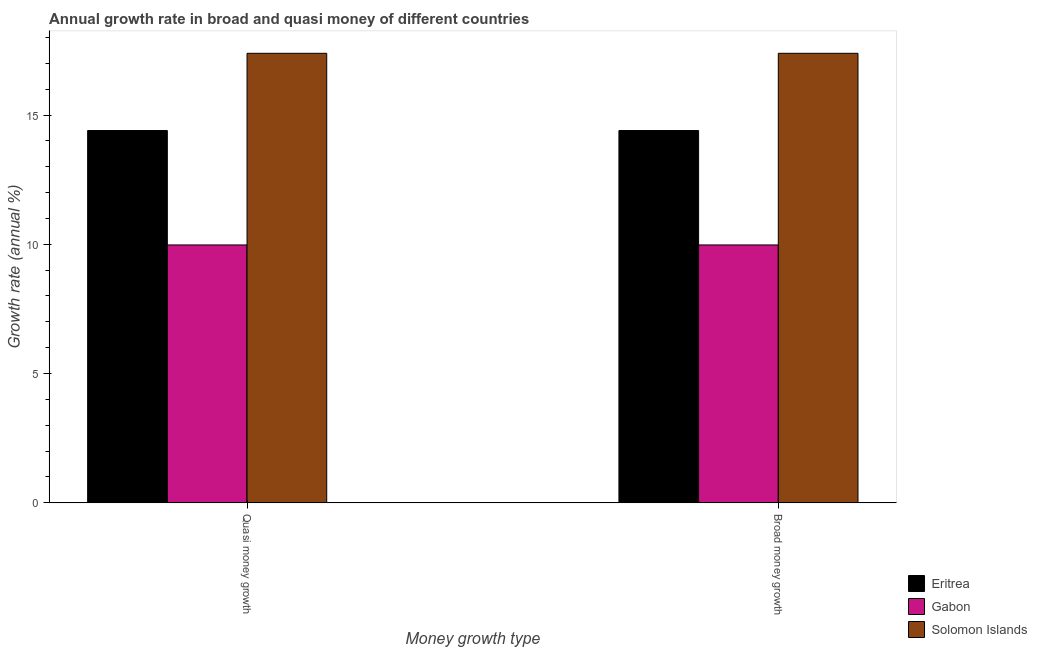How many groups of bars are there?
Give a very brief answer. 2. How many bars are there on the 2nd tick from the left?
Provide a succinct answer. 3. What is the label of the 2nd group of bars from the left?
Provide a short and direct response. Broad money growth. What is the annual growth rate in broad money in Gabon?
Provide a short and direct response. 9.97. Across all countries, what is the maximum annual growth rate in broad money?
Offer a very short reply. 17.39. Across all countries, what is the minimum annual growth rate in broad money?
Your response must be concise. 9.97. In which country was the annual growth rate in broad money maximum?
Offer a very short reply. Solomon Islands. In which country was the annual growth rate in quasi money minimum?
Your answer should be compact. Gabon. What is the total annual growth rate in quasi money in the graph?
Your response must be concise. 41.76. What is the difference between the annual growth rate in broad money in Eritrea and that in Gabon?
Make the answer very short. 4.43. What is the difference between the annual growth rate in broad money in Eritrea and the annual growth rate in quasi money in Gabon?
Your answer should be compact. 4.43. What is the average annual growth rate in quasi money per country?
Your answer should be very brief. 13.92. What is the ratio of the annual growth rate in quasi money in Solomon Islands to that in Gabon?
Provide a short and direct response. 1.74. In how many countries, is the annual growth rate in broad money greater than the average annual growth rate in broad money taken over all countries?
Ensure brevity in your answer.  2. What does the 2nd bar from the left in Broad money growth represents?
Ensure brevity in your answer.  Gabon. What does the 2nd bar from the right in Quasi money growth represents?
Give a very brief answer. Gabon. How many bars are there?
Provide a short and direct response. 6. How many countries are there in the graph?
Your response must be concise. 3. What is the difference between two consecutive major ticks on the Y-axis?
Your response must be concise. 5. Are the values on the major ticks of Y-axis written in scientific E-notation?
Your answer should be compact. No. Does the graph contain any zero values?
Give a very brief answer. No. How are the legend labels stacked?
Your answer should be very brief. Vertical. What is the title of the graph?
Your response must be concise. Annual growth rate in broad and quasi money of different countries. What is the label or title of the X-axis?
Offer a terse response. Money growth type. What is the label or title of the Y-axis?
Ensure brevity in your answer.  Growth rate (annual %). What is the Growth rate (annual %) of Eritrea in Quasi money growth?
Provide a short and direct response. 14.4. What is the Growth rate (annual %) in Gabon in Quasi money growth?
Ensure brevity in your answer.  9.97. What is the Growth rate (annual %) of Solomon Islands in Quasi money growth?
Ensure brevity in your answer.  17.39. What is the Growth rate (annual %) of Eritrea in Broad money growth?
Provide a succinct answer. 14.4. What is the Growth rate (annual %) of Gabon in Broad money growth?
Your answer should be compact. 9.97. What is the Growth rate (annual %) of Solomon Islands in Broad money growth?
Keep it short and to the point. 17.39. Across all Money growth type, what is the maximum Growth rate (annual %) of Eritrea?
Keep it short and to the point. 14.4. Across all Money growth type, what is the maximum Growth rate (annual %) of Gabon?
Keep it short and to the point. 9.97. Across all Money growth type, what is the maximum Growth rate (annual %) in Solomon Islands?
Keep it short and to the point. 17.39. Across all Money growth type, what is the minimum Growth rate (annual %) in Eritrea?
Ensure brevity in your answer.  14.4. Across all Money growth type, what is the minimum Growth rate (annual %) in Gabon?
Your answer should be compact. 9.97. Across all Money growth type, what is the minimum Growth rate (annual %) of Solomon Islands?
Give a very brief answer. 17.39. What is the total Growth rate (annual %) in Eritrea in the graph?
Offer a terse response. 28.8. What is the total Growth rate (annual %) of Gabon in the graph?
Provide a succinct answer. 19.95. What is the total Growth rate (annual %) in Solomon Islands in the graph?
Keep it short and to the point. 34.77. What is the difference between the Growth rate (annual %) in Gabon in Quasi money growth and that in Broad money growth?
Your response must be concise. 0. What is the difference between the Growth rate (annual %) of Eritrea in Quasi money growth and the Growth rate (annual %) of Gabon in Broad money growth?
Give a very brief answer. 4.43. What is the difference between the Growth rate (annual %) of Eritrea in Quasi money growth and the Growth rate (annual %) of Solomon Islands in Broad money growth?
Your answer should be very brief. -2.99. What is the difference between the Growth rate (annual %) in Gabon in Quasi money growth and the Growth rate (annual %) in Solomon Islands in Broad money growth?
Your answer should be compact. -7.41. What is the average Growth rate (annual %) of Eritrea per Money growth type?
Your answer should be very brief. 14.4. What is the average Growth rate (annual %) of Gabon per Money growth type?
Your answer should be compact. 9.97. What is the average Growth rate (annual %) in Solomon Islands per Money growth type?
Keep it short and to the point. 17.39. What is the difference between the Growth rate (annual %) in Eritrea and Growth rate (annual %) in Gabon in Quasi money growth?
Provide a short and direct response. 4.43. What is the difference between the Growth rate (annual %) in Eritrea and Growth rate (annual %) in Solomon Islands in Quasi money growth?
Offer a terse response. -2.99. What is the difference between the Growth rate (annual %) of Gabon and Growth rate (annual %) of Solomon Islands in Quasi money growth?
Provide a succinct answer. -7.41. What is the difference between the Growth rate (annual %) of Eritrea and Growth rate (annual %) of Gabon in Broad money growth?
Your answer should be compact. 4.43. What is the difference between the Growth rate (annual %) in Eritrea and Growth rate (annual %) in Solomon Islands in Broad money growth?
Keep it short and to the point. -2.99. What is the difference between the Growth rate (annual %) of Gabon and Growth rate (annual %) of Solomon Islands in Broad money growth?
Your answer should be very brief. -7.41. What is the ratio of the Growth rate (annual %) in Eritrea in Quasi money growth to that in Broad money growth?
Offer a very short reply. 1. What is the ratio of the Growth rate (annual %) of Gabon in Quasi money growth to that in Broad money growth?
Provide a short and direct response. 1. What is the difference between the highest and the second highest Growth rate (annual %) in Gabon?
Give a very brief answer. 0. What is the difference between the highest and the lowest Growth rate (annual %) of Eritrea?
Provide a succinct answer. 0. 